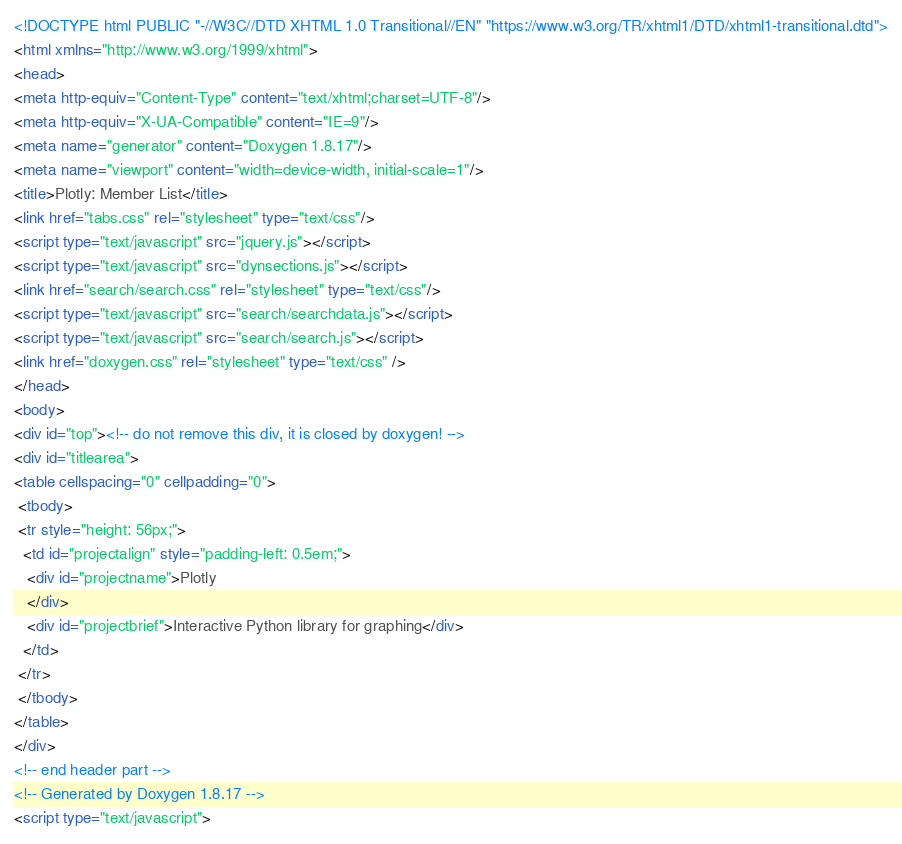<code> <loc_0><loc_0><loc_500><loc_500><_HTML_><!DOCTYPE html PUBLIC "-//W3C//DTD XHTML 1.0 Transitional//EN" "https://www.w3.org/TR/xhtml1/DTD/xhtml1-transitional.dtd">
<html xmlns="http://www.w3.org/1999/xhtml">
<head>
<meta http-equiv="Content-Type" content="text/xhtml;charset=UTF-8"/>
<meta http-equiv="X-UA-Compatible" content="IE=9"/>
<meta name="generator" content="Doxygen 1.8.17"/>
<meta name="viewport" content="width=device-width, initial-scale=1"/>
<title>Plotly: Member List</title>
<link href="tabs.css" rel="stylesheet" type="text/css"/>
<script type="text/javascript" src="jquery.js"></script>
<script type="text/javascript" src="dynsections.js"></script>
<link href="search/search.css" rel="stylesheet" type="text/css"/>
<script type="text/javascript" src="search/searchdata.js"></script>
<script type="text/javascript" src="search/search.js"></script>
<link href="doxygen.css" rel="stylesheet" type="text/css" />
</head>
<body>
<div id="top"><!-- do not remove this div, it is closed by doxygen! -->
<div id="titlearea">
<table cellspacing="0" cellpadding="0">
 <tbody>
 <tr style="height: 56px;">
  <td id="projectalign" style="padding-left: 0.5em;">
   <div id="projectname">Plotly
   </div>
   <div id="projectbrief">Interactive Python library for graphing</div>
  </td>
 </tr>
 </tbody>
</table>
</div>
<!-- end header part -->
<!-- Generated by Doxygen 1.8.17 -->
<script type="text/javascript"></code> 